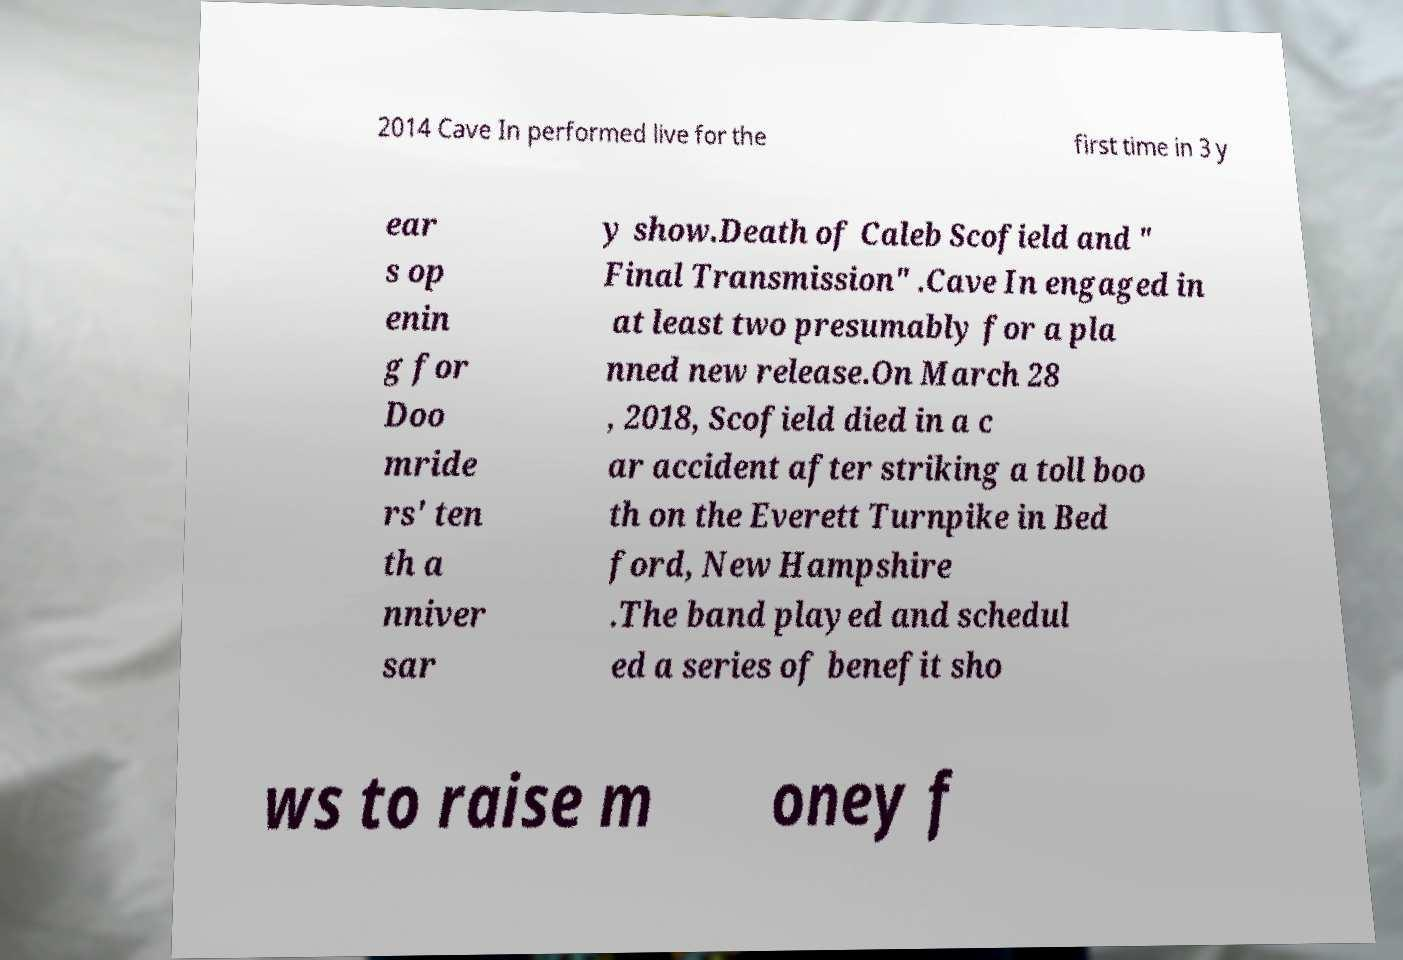I need the written content from this picture converted into text. Can you do that? 2014 Cave In performed live for the first time in 3 y ear s op enin g for Doo mride rs' ten th a nniver sar y show.Death of Caleb Scofield and " Final Transmission" .Cave In engaged in at least two presumably for a pla nned new release.On March 28 , 2018, Scofield died in a c ar accident after striking a toll boo th on the Everett Turnpike in Bed ford, New Hampshire .The band played and schedul ed a series of benefit sho ws to raise m oney f 